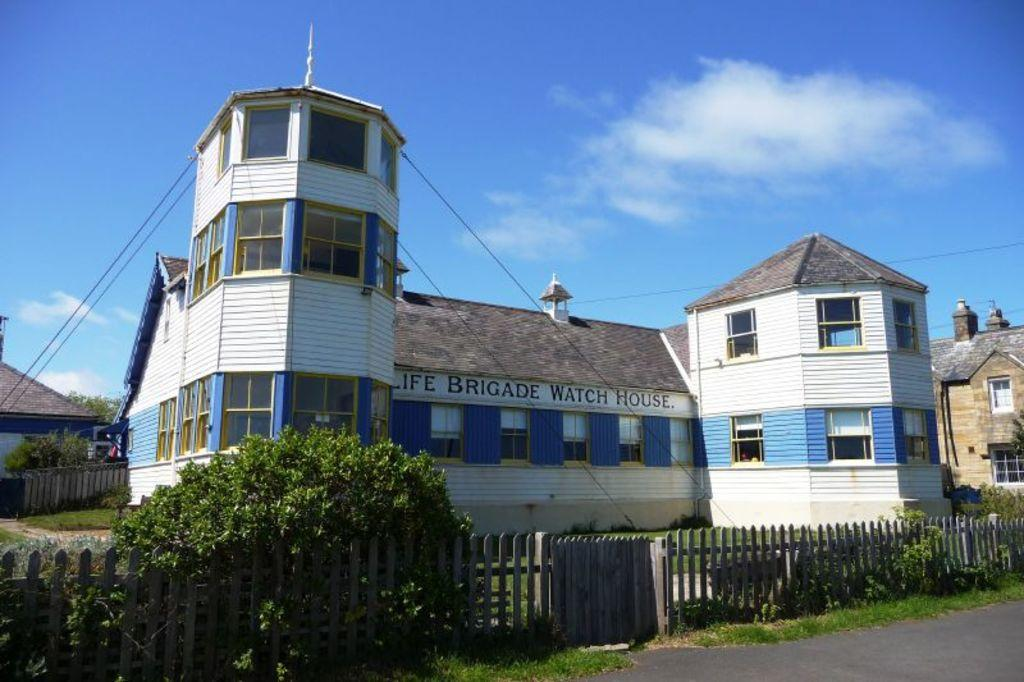What type of surface can be seen in the image? There is a road in the image. What type of vegetation is present in the image? There is grass, plants, and trees in the image. What type of structures are visible in the image? There are fences and buildings with windows in the image. What else can be seen in the image? There are wires and clouds in the sky visible in the background of the image. Where are the dolls playing with the clock in the image? There are no dolls or clocks present in the image. What type of ice can be seen melting on the road in the image? There is no ice present in the image; it only features a road, grass, plants, fences, buildings, trees, wires, and clouds in the sky. 